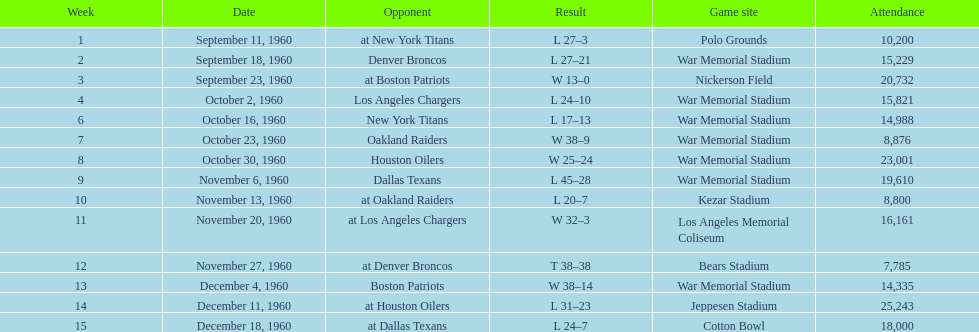In a single game, what was the biggest point difference? 29. Parse the full table. {'header': ['Week', 'Date', 'Opponent', 'Result', 'Game site', 'Attendance'], 'rows': [['1', 'September 11, 1960', 'at New York Titans', 'L 27–3', 'Polo Grounds', '10,200'], ['2', 'September 18, 1960', 'Denver Broncos', 'L 27–21', 'War Memorial Stadium', '15,229'], ['3', 'September 23, 1960', 'at Boston Patriots', 'W 13–0', 'Nickerson Field', '20,732'], ['4', 'October 2, 1960', 'Los Angeles Chargers', 'L 24–10', 'War Memorial Stadium', '15,821'], ['6', 'October 16, 1960', 'New York Titans', 'L 17–13', 'War Memorial Stadium', '14,988'], ['7', 'October 23, 1960', 'Oakland Raiders', 'W 38–9', 'War Memorial Stadium', '8,876'], ['8', 'October 30, 1960', 'Houston Oilers', 'W 25–24', 'War Memorial Stadium', '23,001'], ['9', 'November 6, 1960', 'Dallas Texans', 'L 45–28', 'War Memorial Stadium', '19,610'], ['10', 'November 13, 1960', 'at Oakland Raiders', 'L 20–7', 'Kezar Stadium', '8,800'], ['11', 'November 20, 1960', 'at Los Angeles Chargers', 'W 32–3', 'Los Angeles Memorial Coliseum', '16,161'], ['12', 'November 27, 1960', 'at Denver Broncos', 'T 38–38', 'Bears Stadium', '7,785'], ['13', 'December 4, 1960', 'Boston Patriots', 'W 38–14', 'War Memorial Stadium', '14,335'], ['14', 'December 11, 1960', 'at Houston Oilers', 'L 31–23', 'Jeppesen Stadium', '25,243'], ['15', 'December 18, 1960', 'at Dallas Texans', 'L 24–7', 'Cotton Bowl', '18,000']]} 